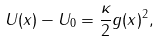<formula> <loc_0><loc_0><loc_500><loc_500>U ( x ) - U _ { 0 } = \frac { \kappa } { 2 } g ( x ) ^ { 2 } ,</formula> 